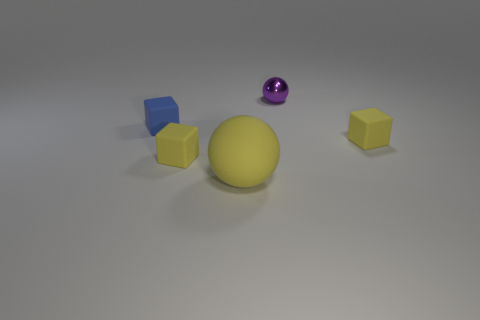What is the shape of the large thing that is the same material as the blue cube?
Give a very brief answer. Sphere. There is a blue rubber object; does it have the same shape as the tiny yellow thing right of the big yellow matte thing?
Give a very brief answer. Yes. What material is the tiny yellow thing that is on the right side of the yellow block left of the big yellow rubber ball?
Offer a terse response. Rubber. Are there the same number of tiny blue matte objects in front of the tiny blue matte thing and blocks?
Provide a succinct answer. No. Are there any other things that have the same material as the purple sphere?
Offer a terse response. No. There is a tiny object behind the small blue rubber thing; is it the same color as the rubber thing that is right of the metal sphere?
Your answer should be very brief. No. How many things are behind the tiny blue rubber block and in front of the small blue thing?
Give a very brief answer. 0. What number of other things are the same shape as the tiny blue matte thing?
Offer a very short reply. 2. Is the number of metal spheres left of the blue object greater than the number of small blue rubber cubes?
Your response must be concise. No. What color is the thing on the right side of the tiny purple sphere?
Ensure brevity in your answer.  Yellow. 